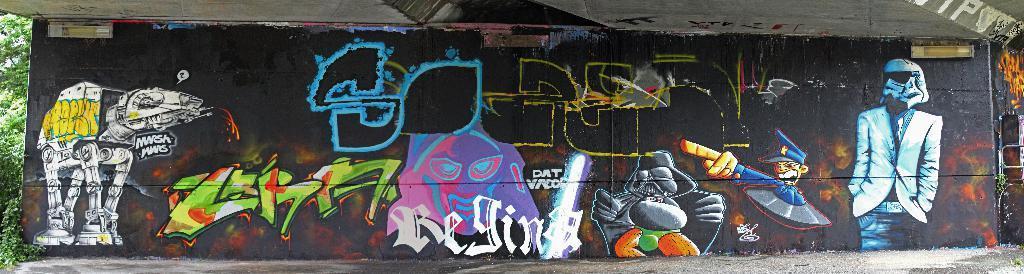In one or two sentences, can you explain what this image depicts? This picture is clicked outside. In the center we can see the pictures of some objects and we can see the picture of a person and we can see the text. At the top there is a roof. In the background we can see the trees and plants. 